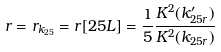Convert formula to latex. <formula><loc_0><loc_0><loc_500><loc_500>r = r _ { k _ { 2 5 } } = r [ 2 5 L ] = \frac { 1 } { 5 } \frac { K ^ { 2 } ( k ^ { \prime } _ { 2 5 r } ) } { K ^ { 2 } ( k _ { 2 5 r } ) }</formula> 